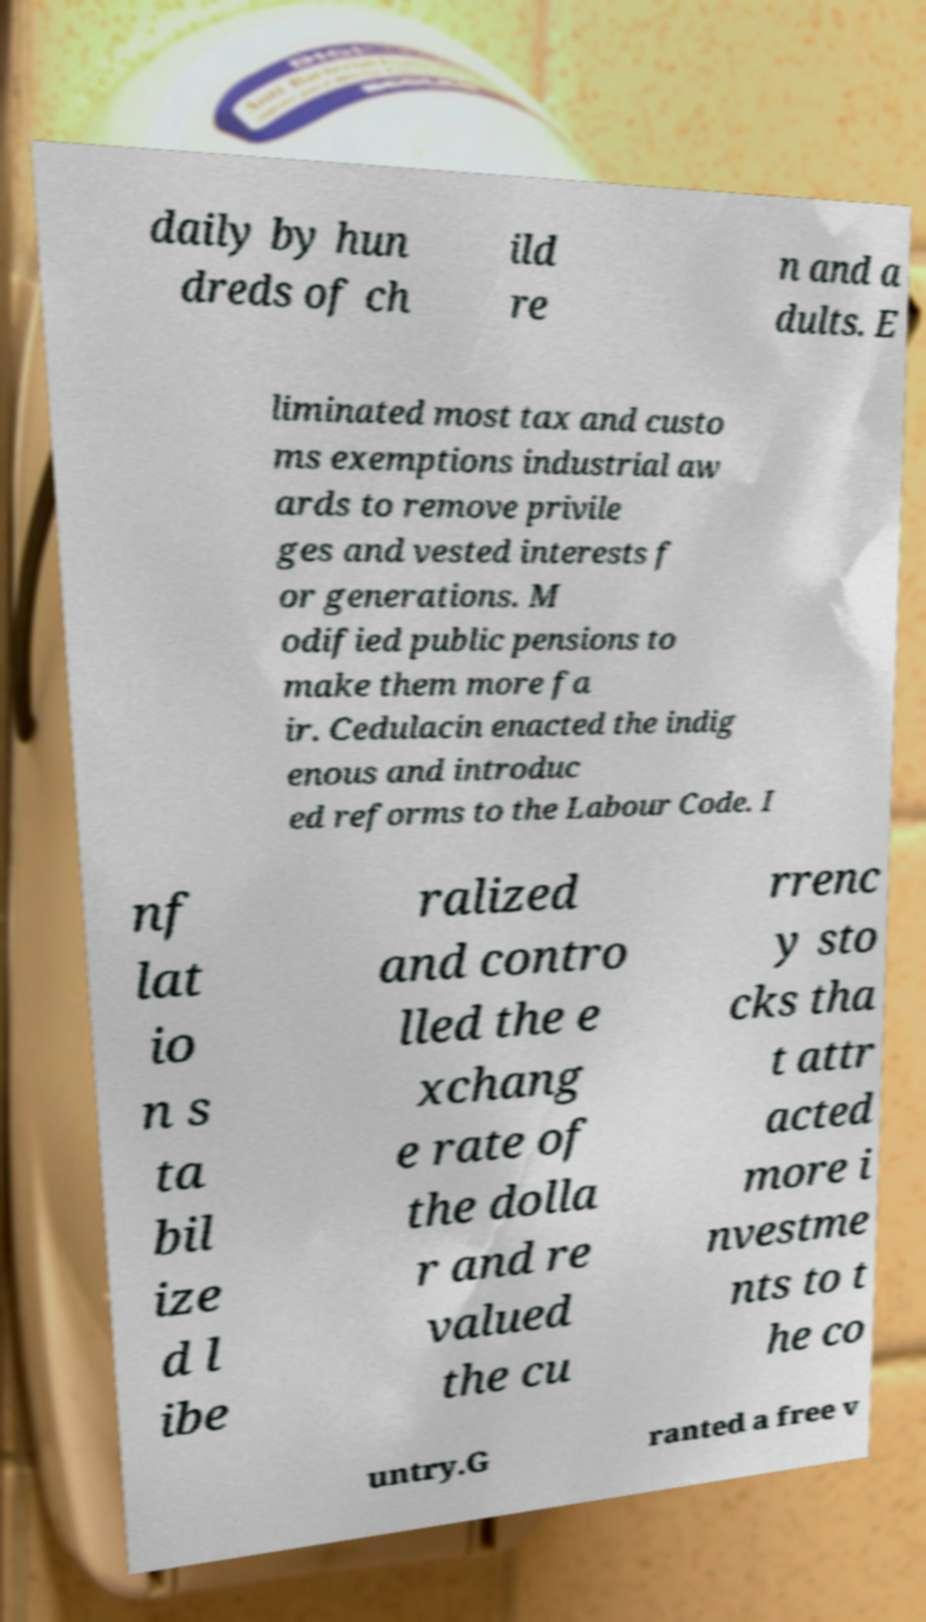Please identify and transcribe the text found in this image. daily by hun dreds of ch ild re n and a dults. E liminated most tax and custo ms exemptions industrial aw ards to remove privile ges and vested interests f or generations. M odified public pensions to make them more fa ir. Cedulacin enacted the indig enous and introduc ed reforms to the Labour Code. I nf lat io n s ta bil ize d l ibe ralized and contro lled the e xchang e rate of the dolla r and re valued the cu rrenc y sto cks tha t attr acted more i nvestme nts to t he co untry.G ranted a free v 